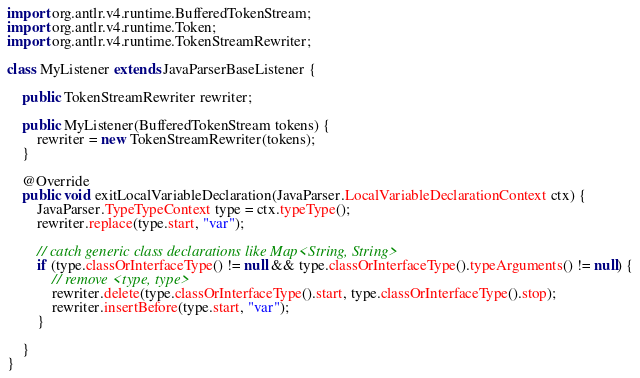Convert code to text. <code><loc_0><loc_0><loc_500><loc_500><_Java_>import org.antlr.v4.runtime.BufferedTokenStream;
import org.antlr.v4.runtime.Token;
import org.antlr.v4.runtime.TokenStreamRewriter;

class MyListener extends JavaParserBaseListener {

    public TokenStreamRewriter rewriter;

    public MyListener(BufferedTokenStream tokens) {
        rewriter = new TokenStreamRewriter(tokens);
    }

    @Override
    public void exitLocalVariableDeclaration(JavaParser.LocalVariableDeclarationContext ctx) {
        JavaParser.TypeTypeContext type = ctx.typeType();
        rewriter.replace(type.start, "var");

        // catch generic class declarations like Map<String, String>
        if (type.classOrInterfaceType() != null && type.classOrInterfaceType().typeArguments() != null) {
            // remove <type, type>
            rewriter.delete(type.classOrInterfaceType().start, type.classOrInterfaceType().stop);
            rewriter.insertBefore(type.start, "var");
        }

    }
}</code> 